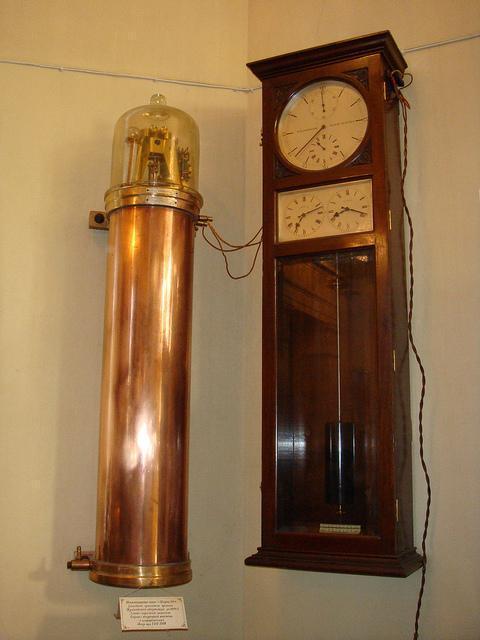What is connected to the long cylinder?
From the following set of four choices, select the accurate answer to respond to the question.
Options: Egg, clock, gargoyle, vacuum. Clock. 